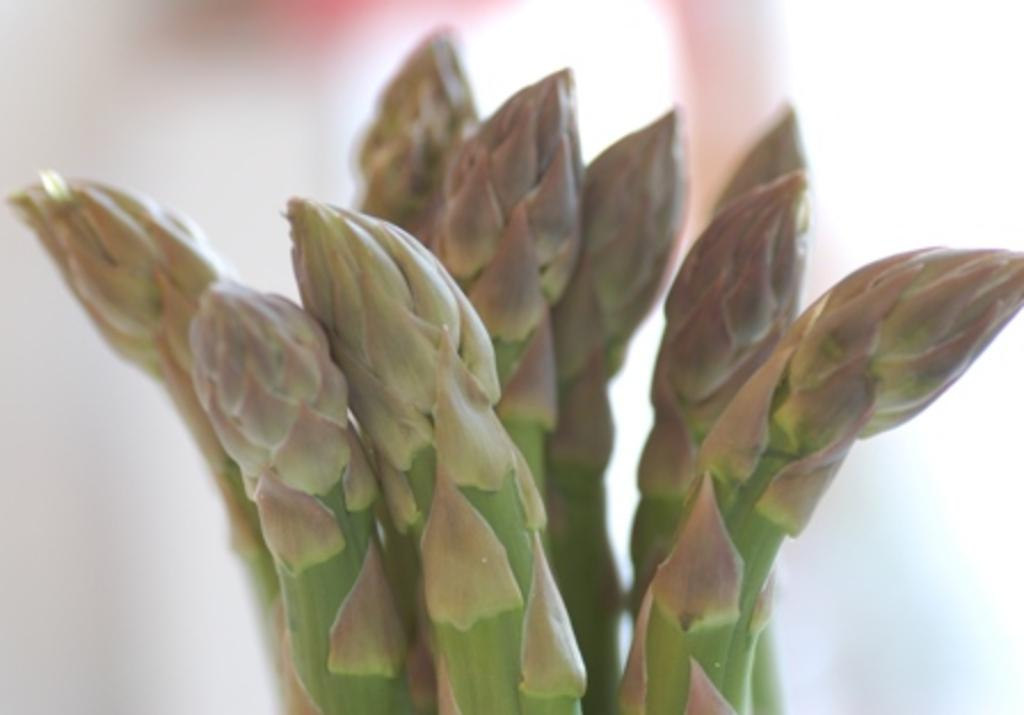What type of plant is in the foreground of the image? There is a cactus in the foreground of the image. Can you describe the background of the image? The background of the image is blurry. What type of mine is visible in the background of the image? There is no mine visible in the image; the background is blurry. What is the opinion of the cactus in the image? The image does not convey an opinion about the cactus; it is simply a photograph of a cactus. 